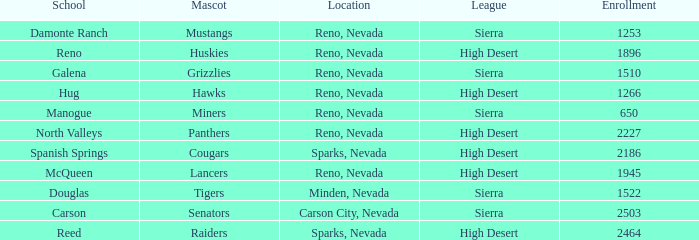Which leagues have Raiders as their mascot? High Desert. 